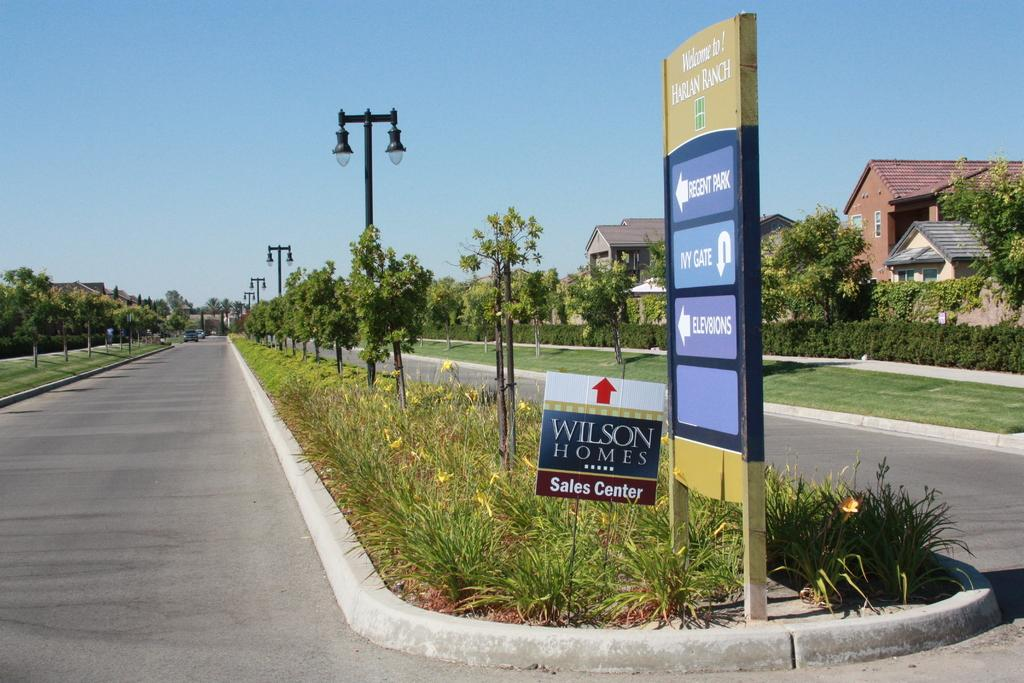What type of objects can be seen in the image? There are boards, plants, grass, trees, poles, lights, houses, and cars on the road in the image. What type of vegetation is present in the image? There are plants, grass, and trees in the image. What structures are visible in the image? There are houses and poles in the image. What type of transportation can be seen in the image? There are cars on the road in the image. What is visible in the background of the image? The sky is visible in the background of the image. How many beads are hanging from the trees in the image? There are no beads hanging from the trees in the image. What is the distance between the houses in the image? The provided facts do not give information about the distance between the houses in the image. 